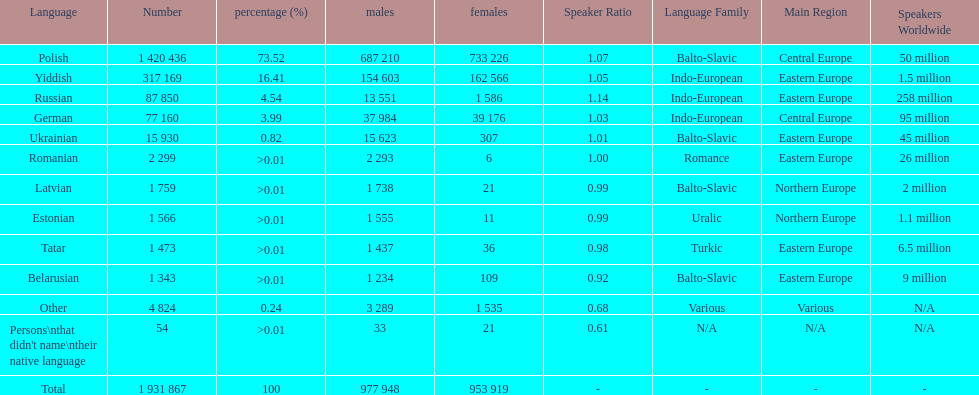What was the next most commonly spoken language in poland after russian? German. 